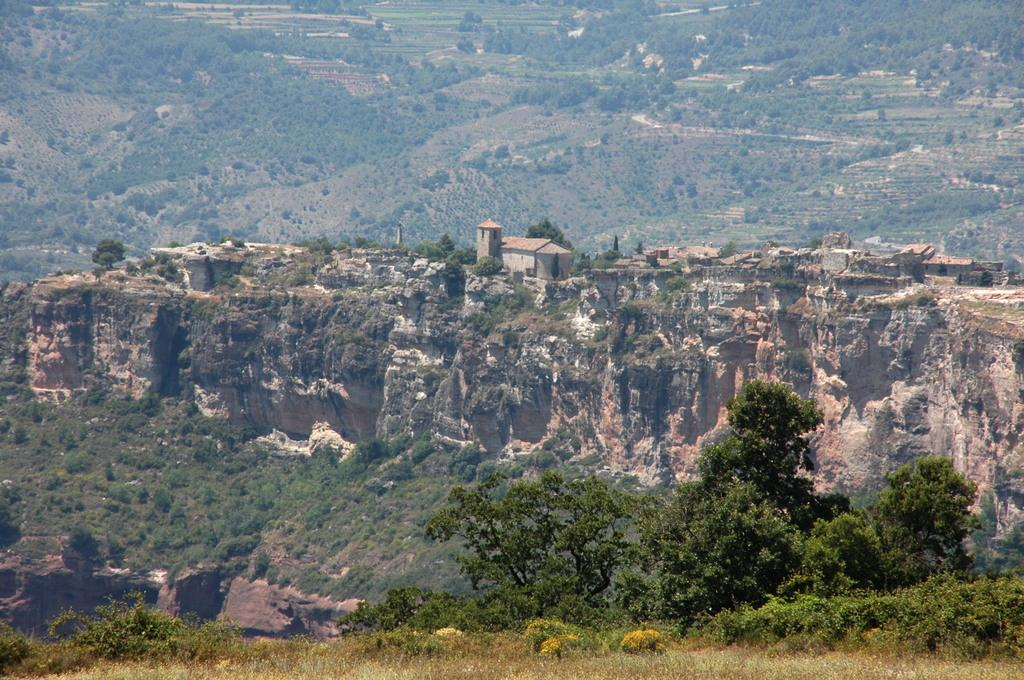What type of vegetation can be seen in the image? There are trees in the image. What is the color of the trees? The trees are green in color. What geographical feature is present in the image? There is a mountain in the image. What structures can be seen on the mountain? There are buildings on the mountain. What can be seen in the background of the image? There are trees and the ground visible in the background of the image. Where is the office located in the image? There is no office present in the image. What type of animal can be seen interacting with the trees in the image? There are no animals present in the image; it only features trees, a mountain, buildings, and the ground. 